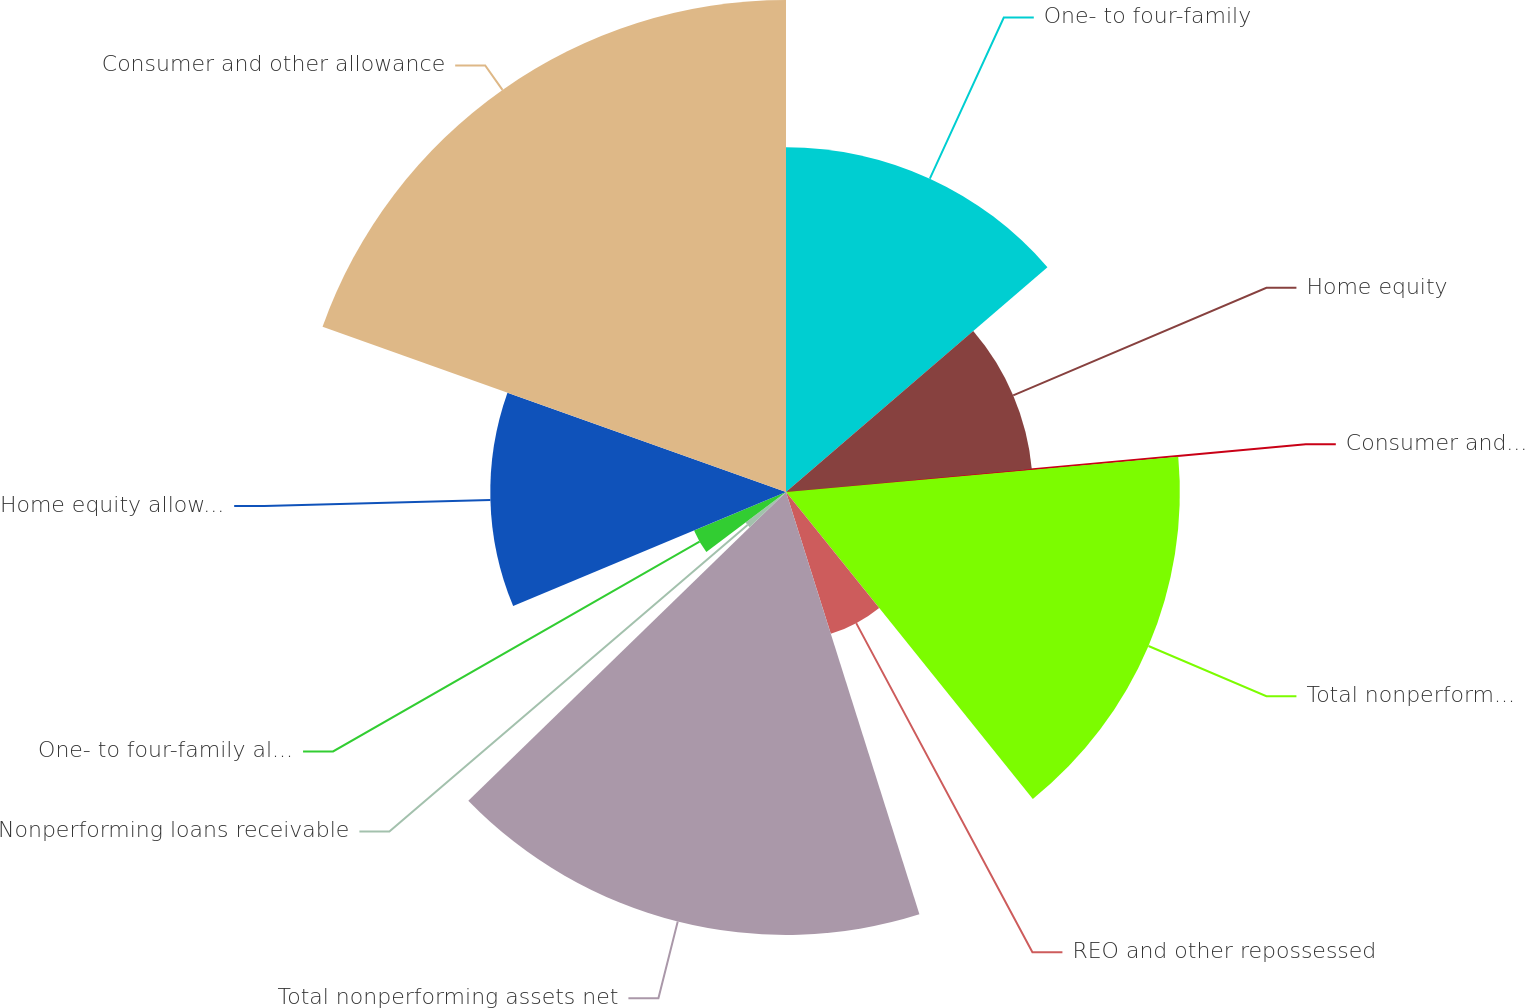Convert chart to OTSL. <chart><loc_0><loc_0><loc_500><loc_500><pie_chart><fcel>One- to four-family<fcel>Home equity<fcel>Consumer and other<fcel>Total nonperforming loans<fcel>REO and other repossessed<fcel>Total nonperforming assets net<fcel>Nonperforming loans receivable<fcel>One- to four-family allowance<fcel>Home equity allowance for loan<fcel>Consumer and other allowance<nl><fcel>13.7%<fcel>9.81%<fcel>0.06%<fcel>15.65%<fcel>5.91%<fcel>17.6%<fcel>2.01%<fcel>3.96%<fcel>11.75%<fcel>19.55%<nl></chart> 